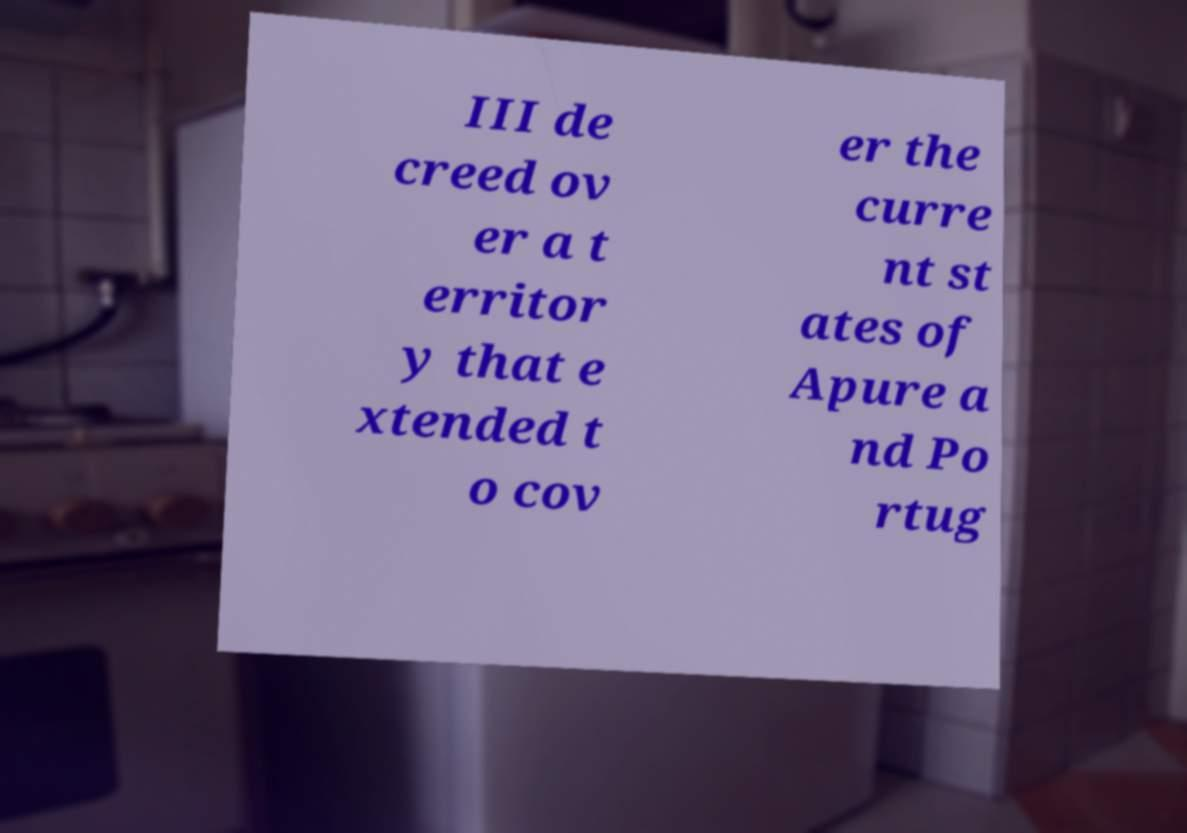Could you assist in decoding the text presented in this image and type it out clearly? III de creed ov er a t erritor y that e xtended t o cov er the curre nt st ates of Apure a nd Po rtug 